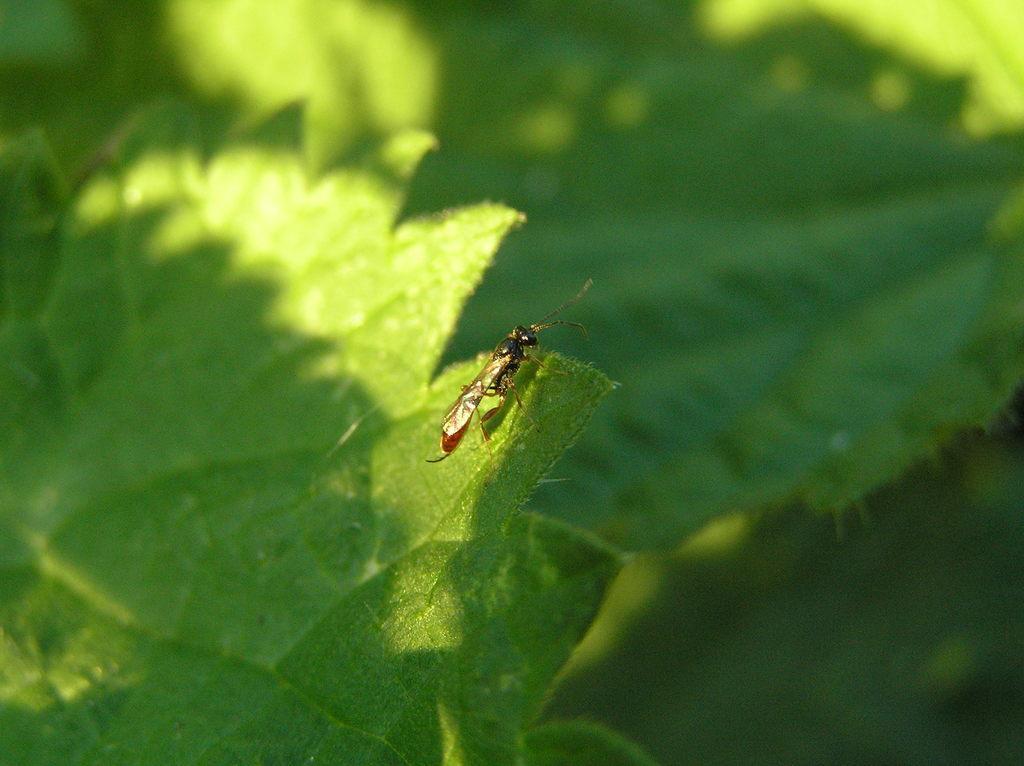In one or two sentences, can you explain what this image depicts? In this image, we can see an insect on the leaf. Background we can see the blur view. Here we can see greenery. 